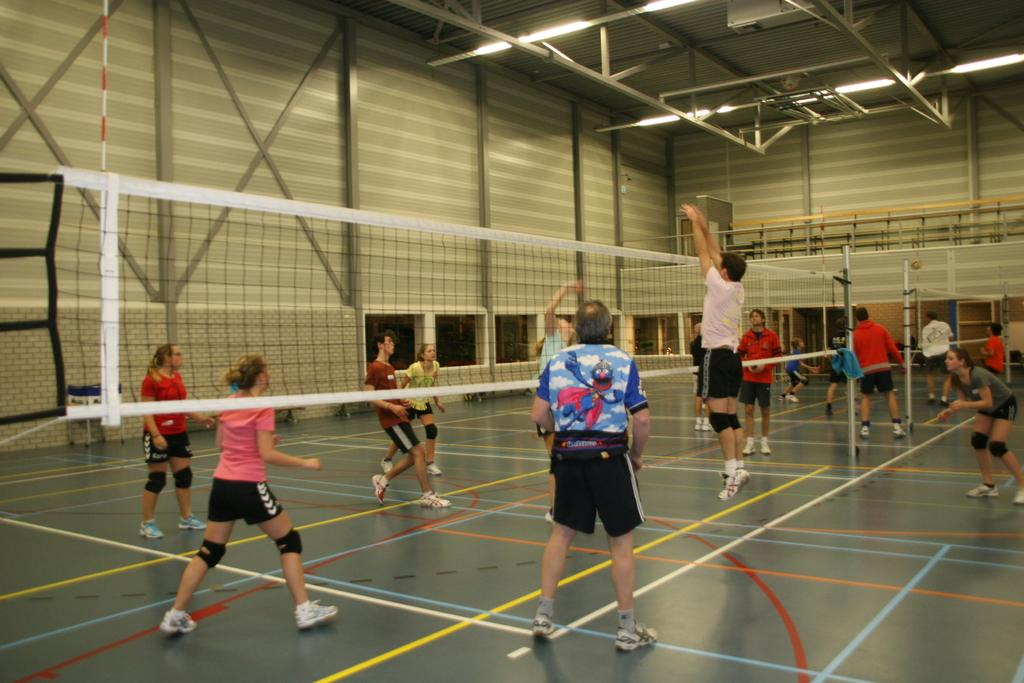Who is present in the image? There are people in the image. What are the people doing in the image? The people are playing volleyball. What is used to separate the two teams in the game? There is a net in the middle of the playing area. Where is the playground located in the image? There is no playground present in the image; it features people playing volleyball. What type of system is being used to control the game in the image? There is no system controlling the game in the image; it is a simple game of volleyball with a net separating the two teams. 